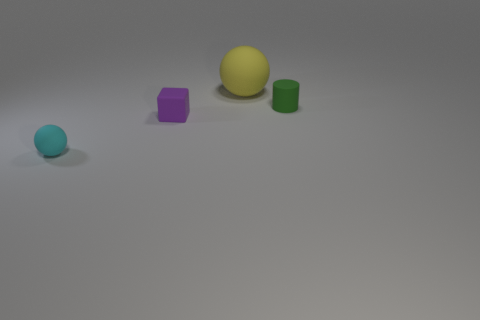There is a tiny object that is right of the tiny cyan matte thing and left of the big sphere; what is its shape?
Your answer should be very brief. Cube. Is the number of small green matte cylinders that are in front of the small cyan thing the same as the number of big green cubes?
Your response must be concise. Yes. What number of things are shiny balls or small rubber things to the right of the yellow matte thing?
Your response must be concise. 1. Are there any other tiny matte things that have the same shape as the small green matte object?
Keep it short and to the point. No. Are there an equal number of green cylinders to the left of the small green cylinder and yellow objects that are in front of the small cyan rubber object?
Your response must be concise. Yes. Is there any other thing that is the same size as the purple matte block?
Make the answer very short. Yes. How many yellow objects are tiny matte cubes or balls?
Provide a succinct answer. 1. How many yellow balls are the same size as the cylinder?
Make the answer very short. 0. The tiny matte thing that is in front of the green thing and right of the small sphere is what color?
Offer a very short reply. Purple. Are there more small purple things behind the small matte cube than tiny matte cylinders?
Make the answer very short. No. 